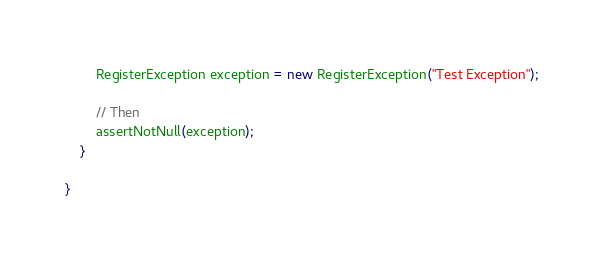<code> <loc_0><loc_0><loc_500><loc_500><_Java_>        RegisterException exception = new RegisterException("Test Exception");

        // Then
        assertNotNull(exception);
    }

}</code> 